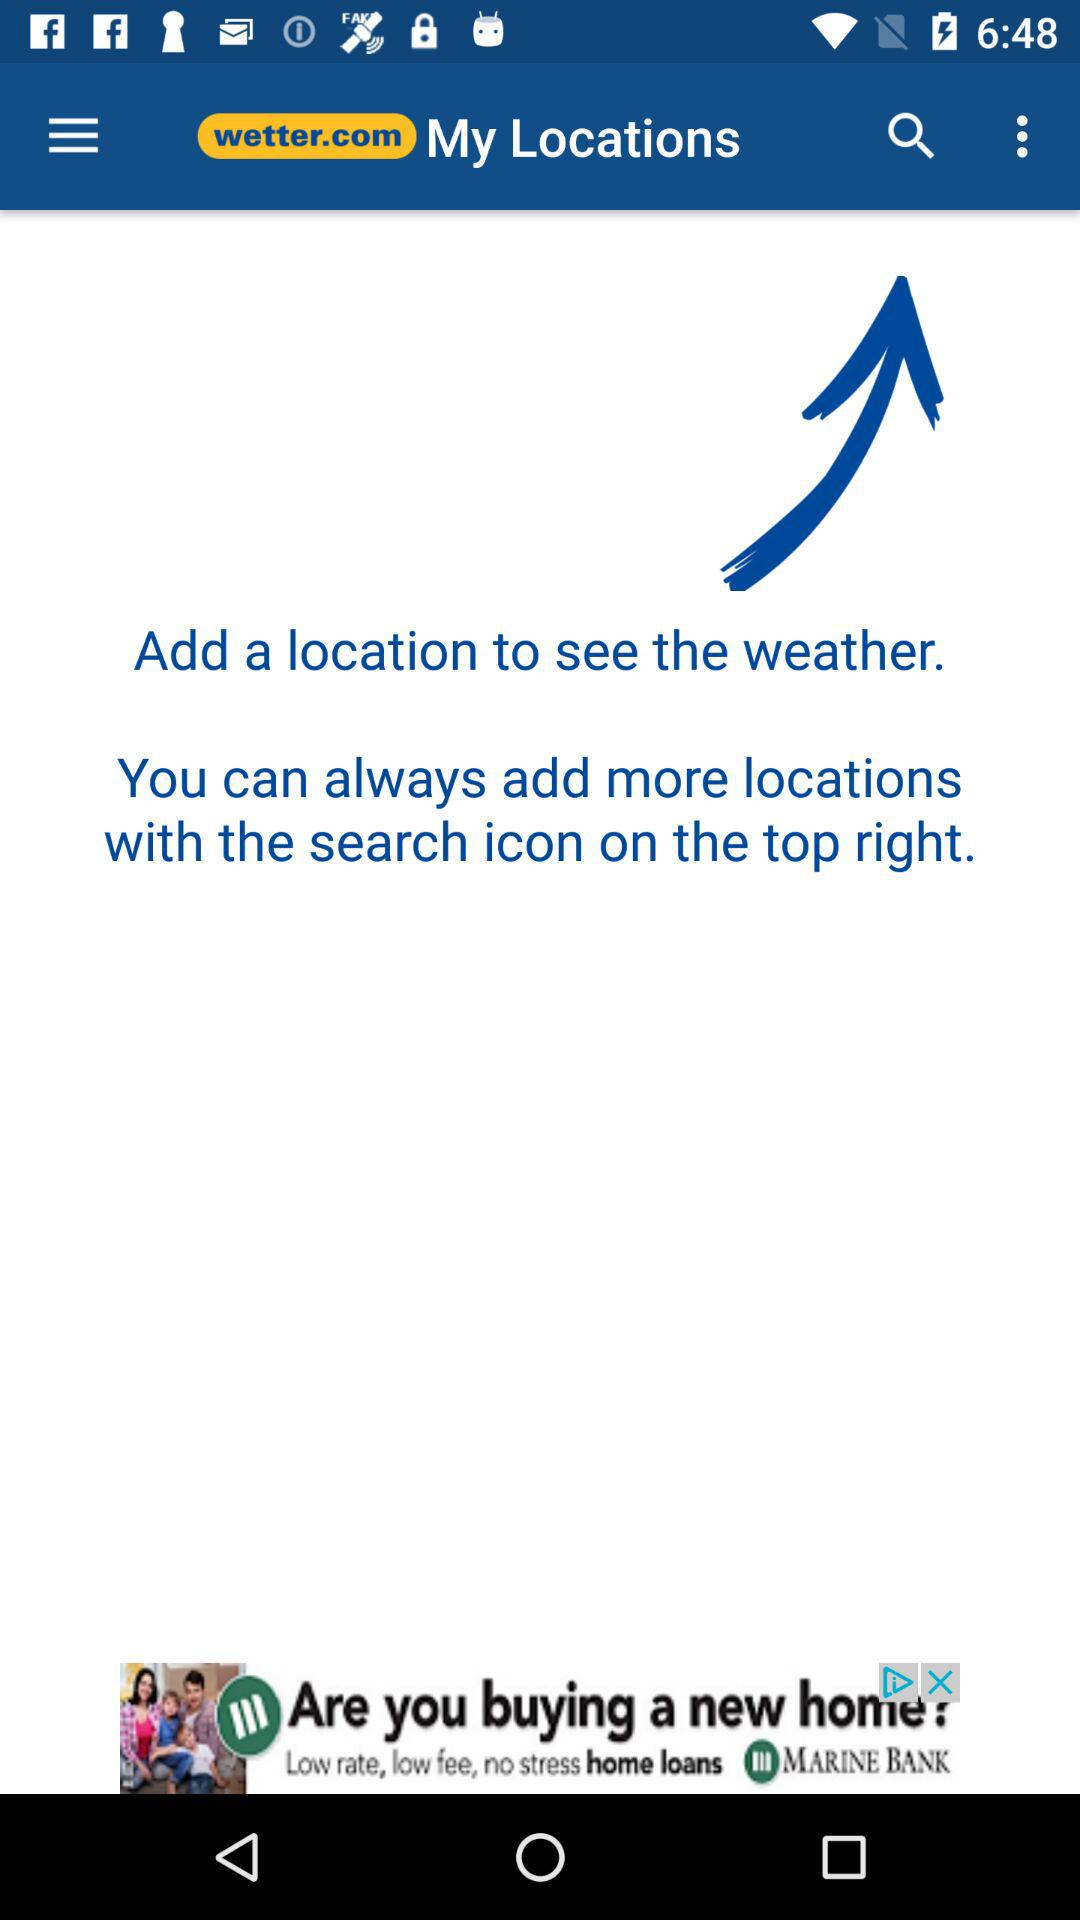What is the application name? The application name is "wetter.com". 